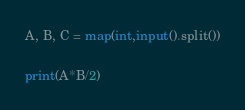<code> <loc_0><loc_0><loc_500><loc_500><_Python_>A, B, C = map(int,input().split())

print(A*B/2)</code> 